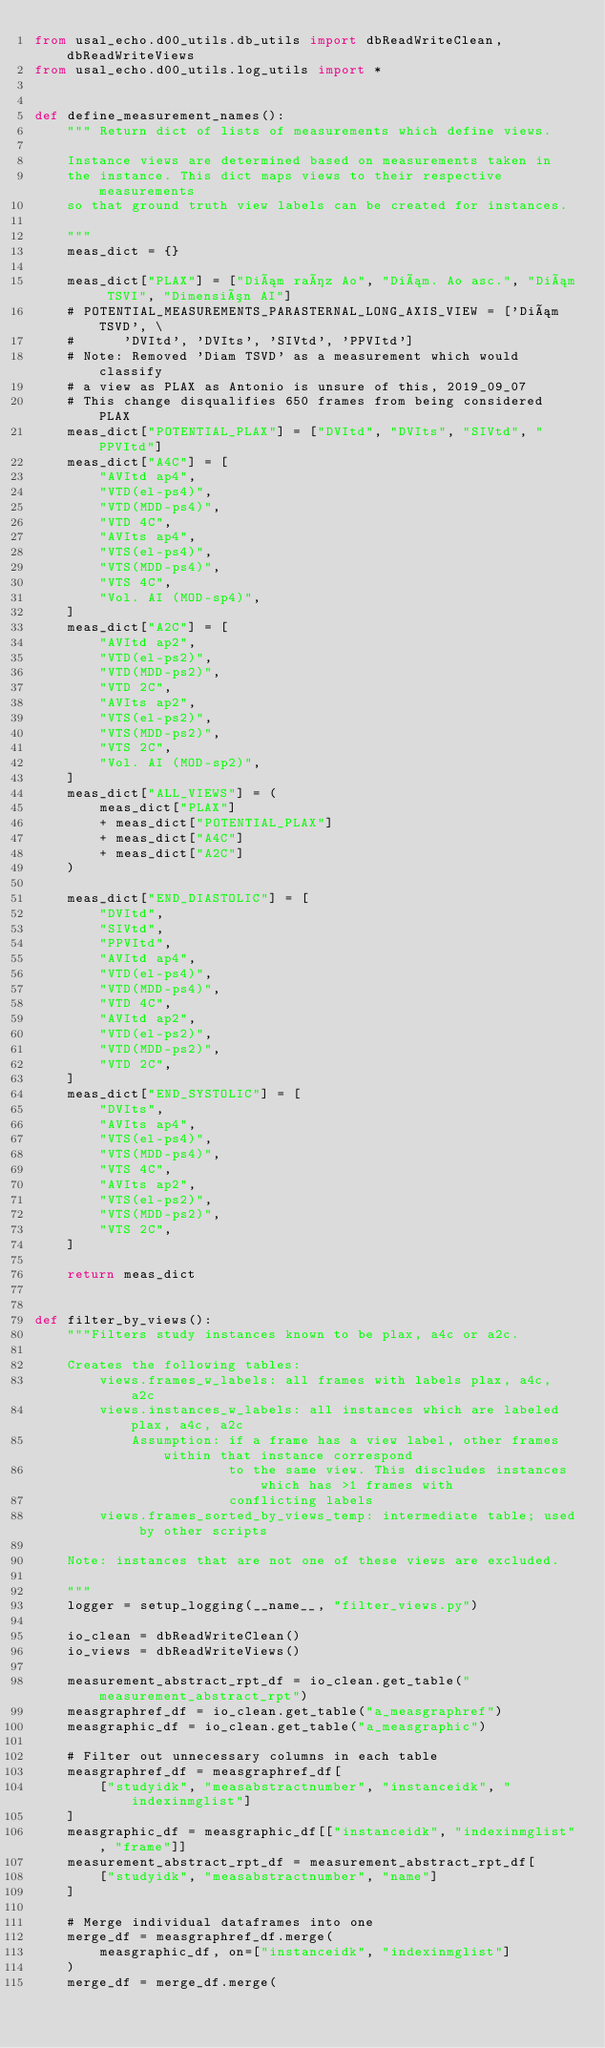Convert code to text. <code><loc_0><loc_0><loc_500><loc_500><_Python_>from usal_echo.d00_utils.db_utils import dbReadWriteClean, dbReadWriteViews
from usal_echo.d00_utils.log_utils import *


def define_measurement_names():
    """ Return dict of lists of measurements which define views.
    
    Instance views are determined based on measurements taken in 
    the instance. This dict maps views to their respective measurements
    so that ground truth view labels can be created for instances. 
    
    """
    meas_dict = {}

    meas_dict["PLAX"] = ["Diám raíz Ao", "Diám. Ao asc.", "Diám TSVI", "Dimensión AI"]
    # POTENTIAL_MEASUREMENTS_PARASTERNAL_LONG_AXIS_VIEW = ['Diám TSVD', \
    #      'DVItd', 'DVIts', 'SIVtd', 'PPVItd']
    # Note: Removed 'Diam TSVD' as a measurement which would classify
    # a view as PLAX as Antonio is unsure of this, 2019_09_07
    # This change disqualifies 650 frames from being considered PLAX
    meas_dict["POTENTIAL_PLAX"] = ["DVItd", "DVIts", "SIVtd", "PPVItd"]
    meas_dict["A4C"] = [
        "AVItd ap4",
        "VTD(el-ps4)",
        "VTD(MDD-ps4)",
        "VTD 4C",
        "AVIts ap4",
        "VTS(el-ps4)",
        "VTS(MDD-ps4)",
        "VTS 4C",
        "Vol. AI (MOD-sp4)",
    ]
    meas_dict["A2C"] = [
        "AVItd ap2",
        "VTD(el-ps2)",
        "VTD(MDD-ps2)",
        "VTD 2C",
        "AVIts ap2",
        "VTS(el-ps2)",
        "VTS(MDD-ps2)",
        "VTS 2C",
        "Vol. AI (MOD-sp2)",
    ]
    meas_dict["ALL_VIEWS"] = (
        meas_dict["PLAX"]
        + meas_dict["POTENTIAL_PLAX"]
        + meas_dict["A4C"]
        + meas_dict["A2C"]
    )

    meas_dict["END_DIASTOLIC"] = [
        "DVItd",
        "SIVtd",
        "PPVItd",
        "AVItd ap4",
        "VTD(el-ps4)",
        "VTD(MDD-ps4)",
        "VTD 4C",
        "AVItd ap2",
        "VTD(el-ps2)",
        "VTD(MDD-ps2)",
        "VTD 2C",
    ]
    meas_dict["END_SYSTOLIC"] = [
        "DVIts",
        "AVIts ap4",
        "VTS(el-ps4)",
        "VTS(MDD-ps4)",
        "VTS 4C",
        "AVIts ap2",
        "VTS(el-ps2)",
        "VTS(MDD-ps2)",
        "VTS 2C",
    ]

    return meas_dict


def filter_by_views():
    """Filters study instances known to be plax, a4c or a2c.
    
    Creates the following tables:
        views.frames_w_labels: all frames with labels plax, a4c, a2c
        views.instances_w_labels: all instances which are labeled plax, a4c, a2c
            Assumption: if a frame has a view label, other frames within that instance correspond 
                        to the same view. This discludes instances which has >1 frames with 
                        conflicting labels
        views.frames_sorted_by_views_temp: intermediate table; used by other scripts
        
    Note: instances that are not one of these views are excluded.
        
    """
    logger = setup_logging(__name__, "filter_views.py")

    io_clean = dbReadWriteClean()
    io_views = dbReadWriteViews()

    measurement_abstract_rpt_df = io_clean.get_table("measurement_abstract_rpt")
    measgraphref_df = io_clean.get_table("a_measgraphref")
    measgraphic_df = io_clean.get_table("a_measgraphic")

    # Filter out unnecessary columns in each table
    measgraphref_df = measgraphref_df[
        ["studyidk", "measabstractnumber", "instanceidk", "indexinmglist"]
    ]
    measgraphic_df = measgraphic_df[["instanceidk", "indexinmglist", "frame"]]
    measurement_abstract_rpt_df = measurement_abstract_rpt_df[
        ["studyidk", "measabstractnumber", "name"]
    ]

    # Merge individual dataframes into one
    merge_df = measgraphref_df.merge(
        measgraphic_df, on=["instanceidk", "indexinmglist"]
    )
    merge_df = merge_df.merge(</code> 